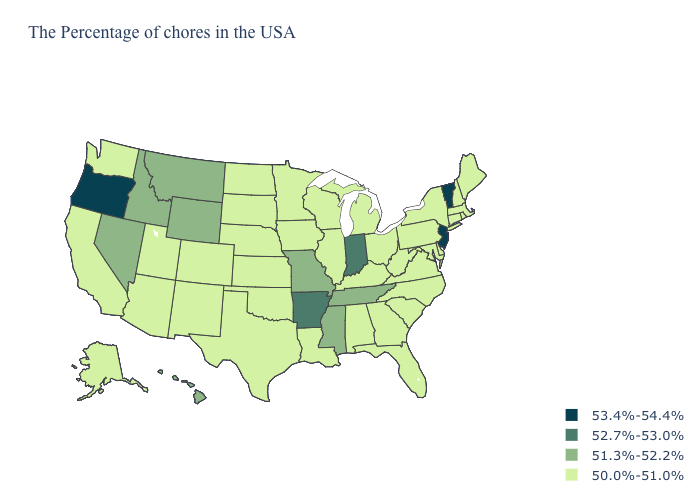Does Virginia have the highest value in the South?
Keep it brief. No. How many symbols are there in the legend?
Keep it brief. 4. What is the value of Idaho?
Quick response, please. 51.3%-52.2%. What is the lowest value in the South?
Answer briefly. 50.0%-51.0%. Name the states that have a value in the range 51.3%-52.2%?
Short answer required. Tennessee, Mississippi, Missouri, Wyoming, Montana, Idaho, Nevada, Hawaii. Does the first symbol in the legend represent the smallest category?
Write a very short answer. No. What is the value of Massachusetts?
Short answer required. 50.0%-51.0%. Does Idaho have a higher value than South Carolina?
Short answer required. Yes. Which states have the lowest value in the MidWest?
Give a very brief answer. Ohio, Michigan, Wisconsin, Illinois, Minnesota, Iowa, Kansas, Nebraska, South Dakota, North Dakota. Which states have the highest value in the USA?
Answer briefly. Vermont, New Jersey, Oregon. What is the lowest value in the West?
Short answer required. 50.0%-51.0%. Name the states that have a value in the range 52.7%-53.0%?
Concise answer only. Indiana, Arkansas. Which states have the lowest value in the Northeast?
Write a very short answer. Maine, Massachusetts, Rhode Island, New Hampshire, Connecticut, New York, Pennsylvania. What is the value of Maryland?
Be succinct. 50.0%-51.0%. 